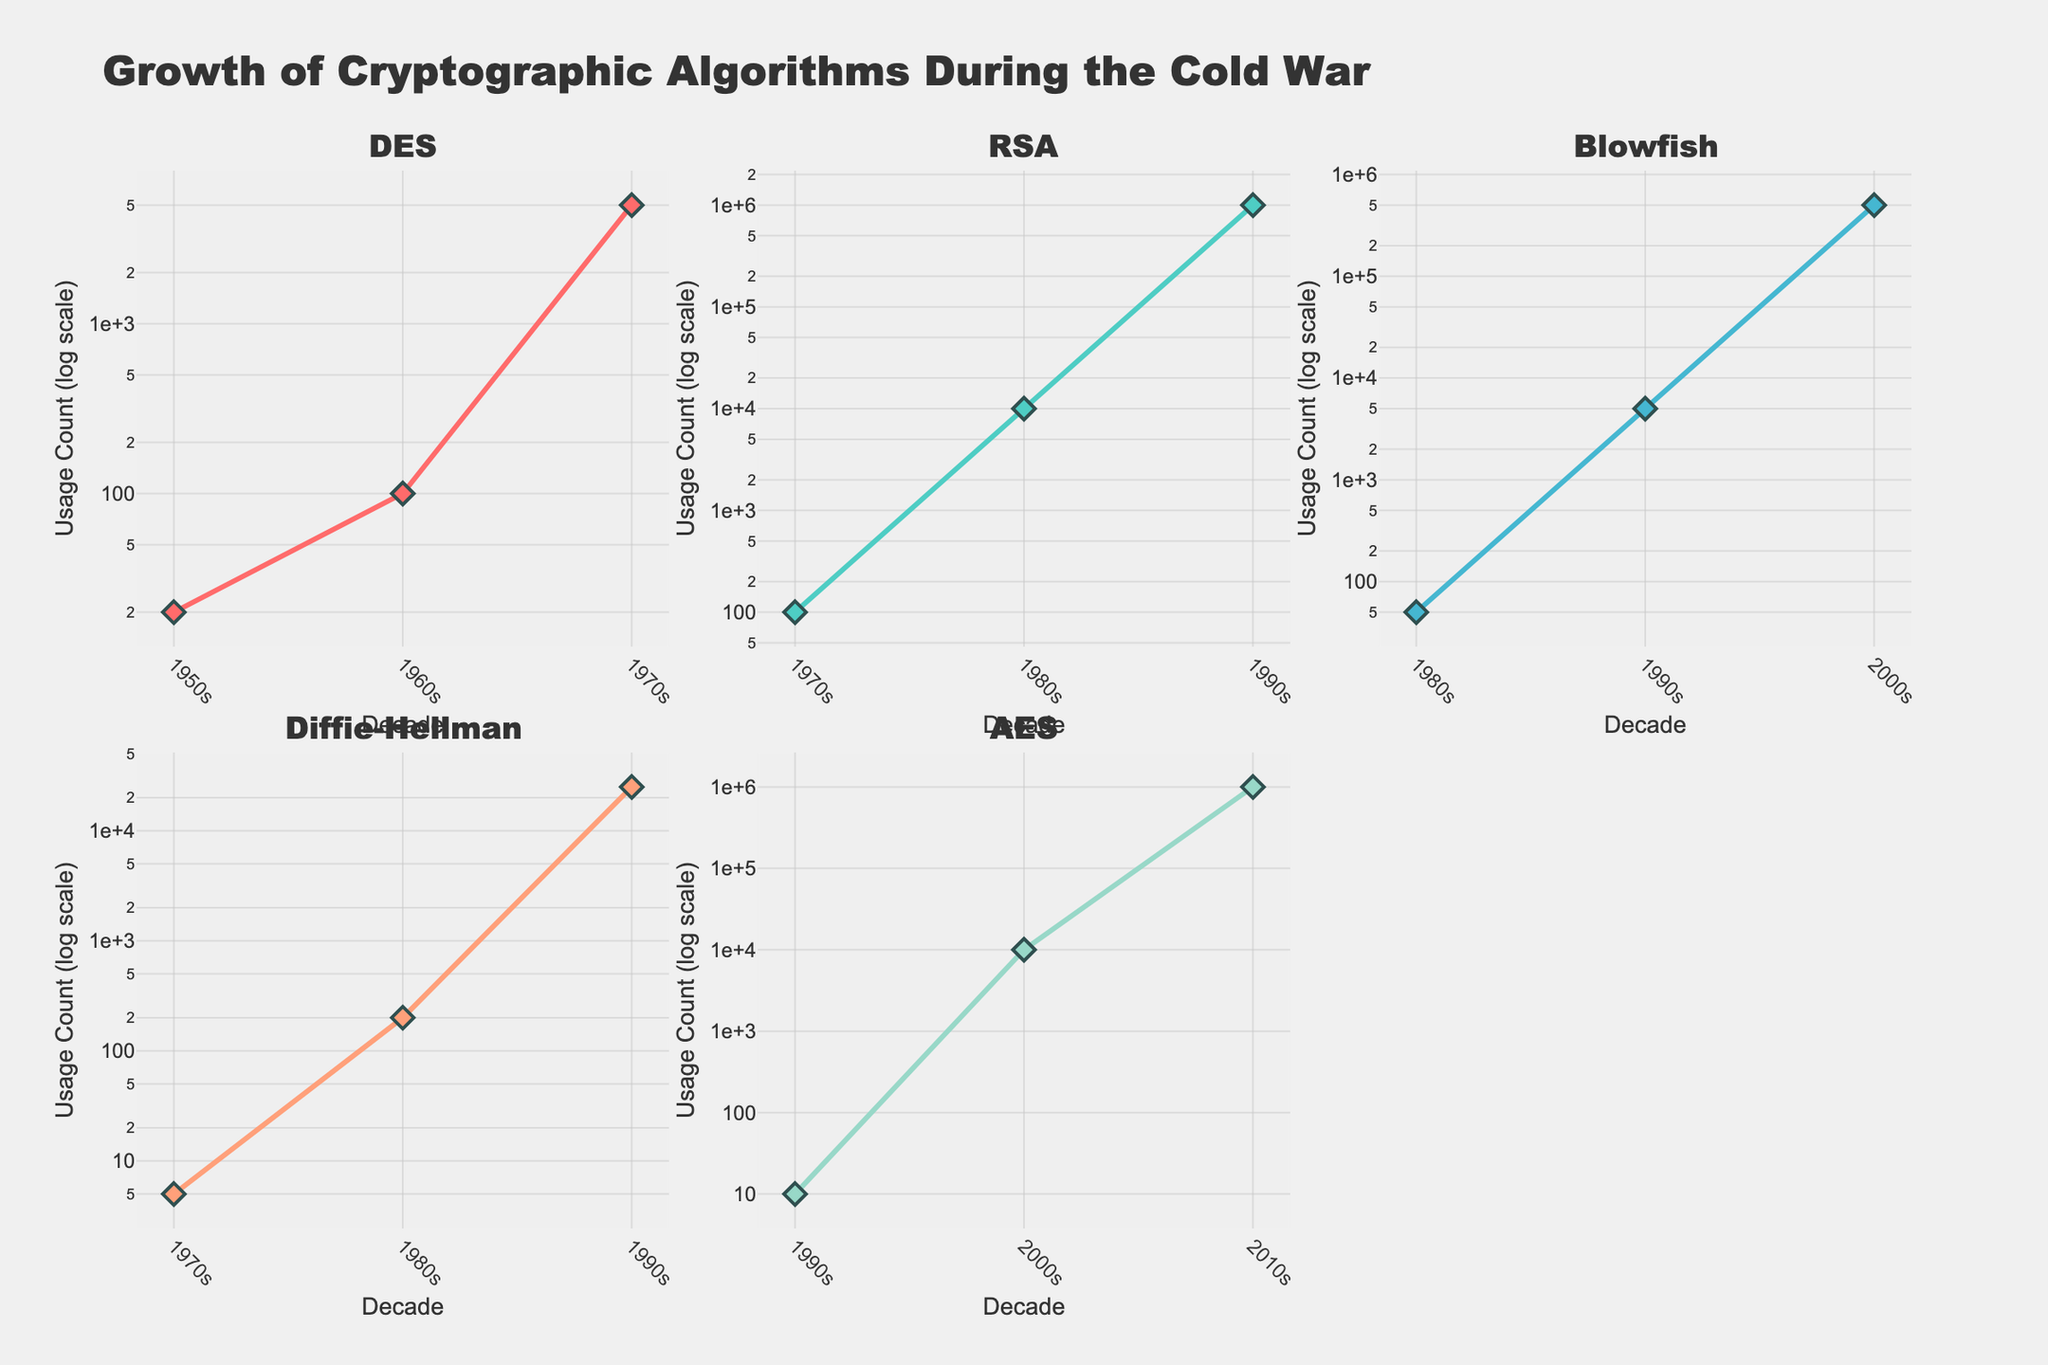What is the title of the figure? The title is displayed at the top center of the figure in bold text. It summarizes the main topic of the figure.
Answer: Growth of Cryptographic Algorithms During the Cold War How many subplots are there in the figure? The figure has a layout with subplots arranged in a grid. By counting them, you can determine this.
Answer: Six Which decade shows the highest usage count for the RSA algorithm? Look at the subplot for the RSA algorithm and find the decade with the highest y-value on the log scale.
Answer: 1990s What is the median usage count of the DES algorithm over the displayed decades? To find the median, list the usage counts for DES in sorted order: 20, 100, 5000. The median is the middle number.
Answer: 100 Which algorithm had the highest growth in usage count between its first and last recorded decades? For each algorithm, subtract the usage count of the first decade from the last recorded decade and compare these growth values.
Answer: RSA In which decade does the AES algorithm show its first recorded usage count? Find the first decade listed for AES in its subplot.
Answer: 1990s How does the growth rate of Blowfish in the 1990s compare to its growth rate in the 2000s? Calculate the increase in usage count from 1980s to 1990s and from 1990s to 2000s, then compare these two growths.
Answer: The growth rate is higher in the 2000s Which algorithm shows the most consistent growth across all decades it appears in? Examine the rate of increase in usage counts for each decade for each algorithm and determine which one has the most even growth.
Answer: Diffie-Hellman What is the first decade that shows more than 10,000 usage counts for any algorithm? Look at all subplots and identify the earliest decade when any algorithm exceeds a usage count of 10,000.
Answer: 1980s for RSA Between DES and Diffie-Hellman, which algorithm reached 5,000 usage counts first and in which decade? Compare the usage counts of DES and Diffie-Hellman in their respective subplots, and find the earliest decade one of them reaches 5,000.
Answer: DES in the 1970s 